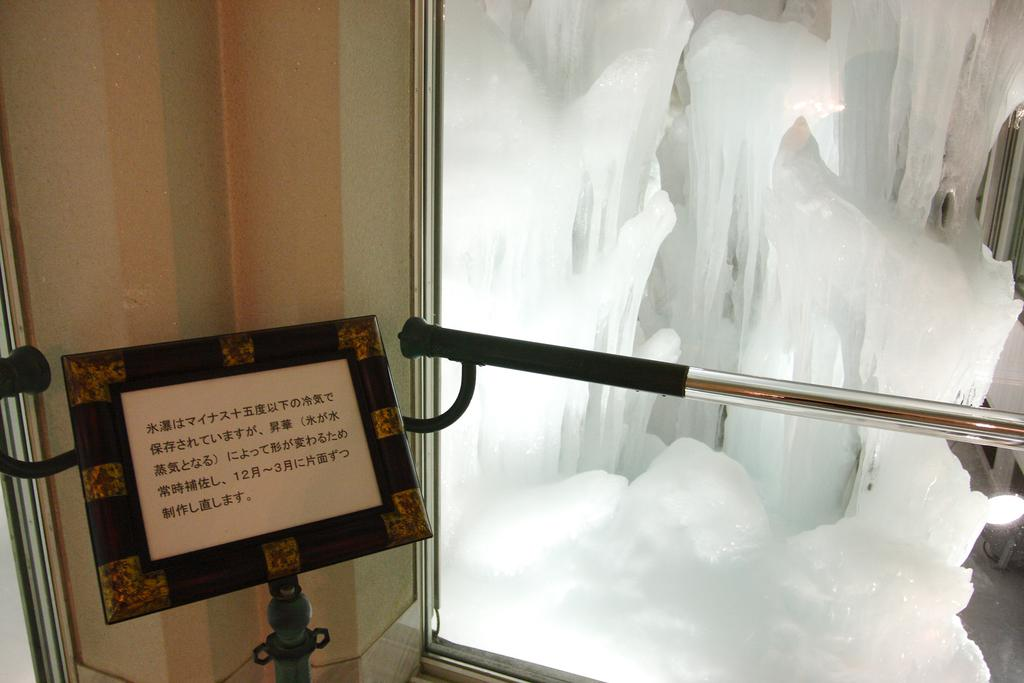What object is located on the right side of the image? There is a metal stand on the right side of the image. What is near the metal stand? There is ice visible near the metal stand. What is on the left side of the image? There is a board on the left side of the image. What is written on the board? There is text on the board. What can be seen in the background of the image? There is a wall in the background of the image. Can you see a knife being used to cut the ice in the image? There is no knife or ice-cutting activity depicted in the image. Is there a crown visible on the board in the image? There is no crown present on the board or anywhere else in the image. 